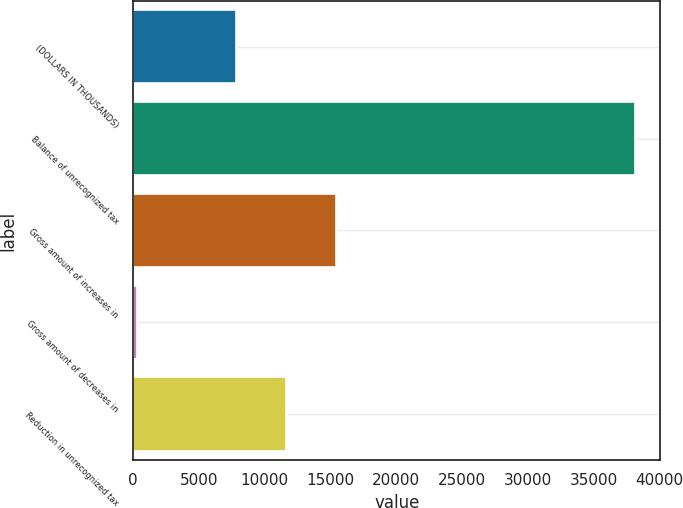<chart> <loc_0><loc_0><loc_500><loc_500><bar_chart><fcel>(DOLLARS IN THOUSANDS)<fcel>Balance of unrecognized tax<fcel>Gross amount of increases in<fcel>Gross amount of decreases in<fcel>Reduction in unrecognized tax<nl><fcel>7846.8<fcel>38162<fcel>15425.6<fcel>268<fcel>11636.2<nl></chart> 